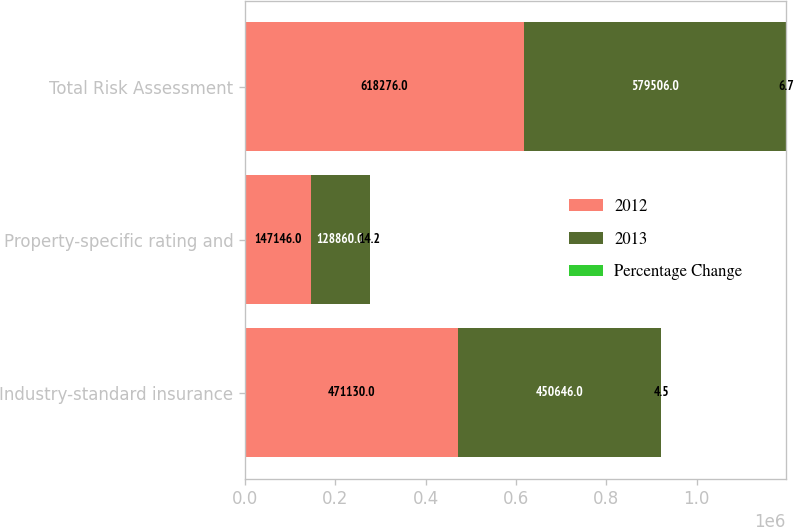Convert chart to OTSL. <chart><loc_0><loc_0><loc_500><loc_500><stacked_bar_chart><ecel><fcel>Industry-standard insurance<fcel>Property-specific rating and<fcel>Total Risk Assessment<nl><fcel>2012<fcel>471130<fcel>147146<fcel>618276<nl><fcel>2013<fcel>450646<fcel>128860<fcel>579506<nl><fcel>Percentage Change<fcel>4.5<fcel>14.2<fcel>6.7<nl></chart> 